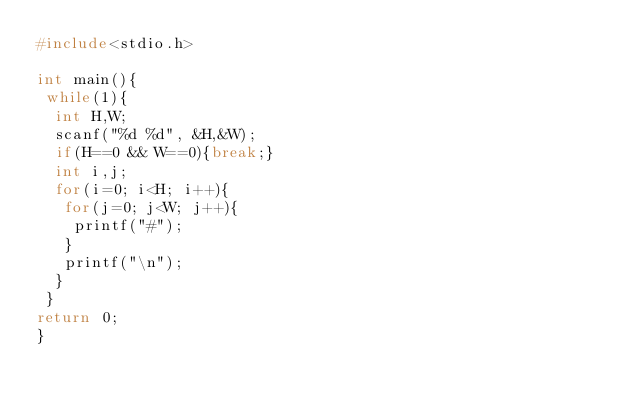Convert code to text. <code><loc_0><loc_0><loc_500><loc_500><_C_>#include<stdio.h>

int main(){
 while(1){
  int H,W;
  scanf("%d %d", &H,&W);
  if(H==0 && W==0){break;}
  int i,j;
  for(i=0; i<H; i++){
   for(j=0; j<W; j++){
    printf("#");
   }
   printf("\n");
  }
 }
return 0;
}</code> 